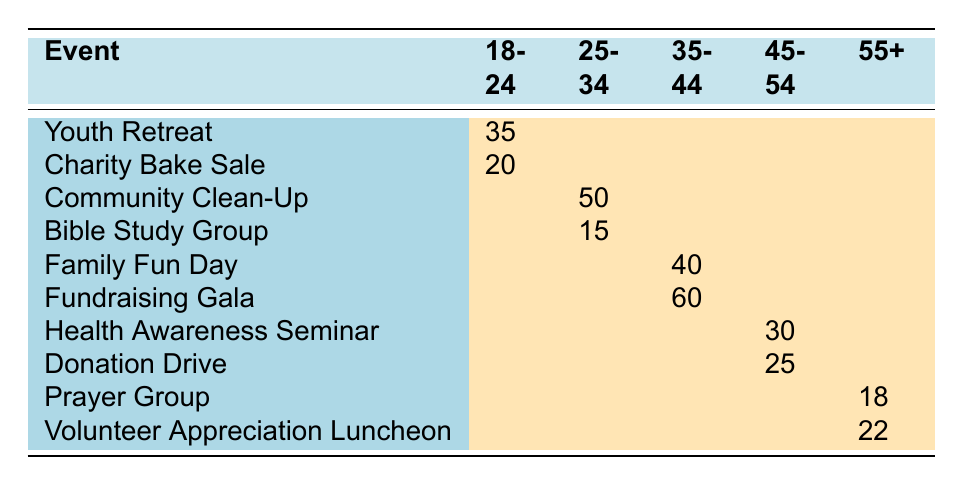What is the total number of participants in the "Youth Retreat"? The table shows 35 participants for the "Youth Retreat" event in the age group of 18-24.
Answer: 35 How many participants attended the "Community Clean-Up"? According to the table, there are 50 participants for the "Community Clean-Up" in the age group of 25-34.
Answer: 50 Which age group had the highest participation in the "Fundraising Gala"? The table lists 60 participants for the "Fundraising Gala," which falls into the age group of 35-44, making it the highest for this event.
Answer: 35-44 What is the total number of participants for events in the 45-54 age group? Adding up the participants from the "Health Awareness Seminar" (30) and "Donation Drive" (25) gives 30 + 25 = 55.
Answer: 55 Which event had participation from the age group 55+? The events listed for the age group of 55+ are "Prayer Group" with 18 participants and "Volunteer Appreciation Luncheon" with 22 participants.
Answer: Prayer Group and Volunteer Appreciation Luncheon Is there any event that had participants from the age group 25-34? Yes, the events for the age group 25-34 are "Community Clean-Up" with 50 participants and "Bible Study Group" with 15 participants, confirming participation.
Answer: Yes What is the average number of participants for the events in the 18-24 age group? The total participants for the events "Youth Retreat" (35) and "Charity Bake Sale" (20) is 35 + 20 = 55. Dividing by the two events gives an average of 55 / 2 = 27.5.
Answer: 27.5 How many more participants were there in the "Family Fun Day" than in the "Health Awareness Seminar"? There were 40 participants in "Family Fun Day" and 30 in "Health Awareness Seminar." The difference is 40 - 30 = 10.
Answer: 10 What is the location of the event with the least participation in the age group 55+? The "Prayer Group" had 18 participants and "Volunteer Appreciation Luncheon" had 22. Therefore, the event with the least participation is "Prayer Group," located at Saint Nicholas Church.
Answer: Saint Nicholas Church Which age group had a lower total participation: 45-54 or 55+? For age group 45-54, total participants are 30 (Health Awareness Seminar) + 25 (Donation Drive) = 55. For 55+, total is 18 (Prayer Group) + 22 (Volunteer Appreciation Luncheon) = 40. Since 40 < 55, the 55+ age group had lower participation.
Answer: 55+ 